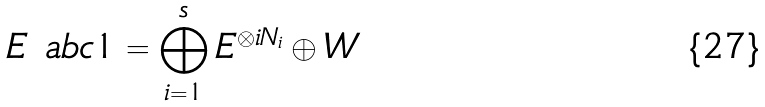<formula> <loc_0><loc_0><loc_500><loc_500>E \ a b c { 1 } = \bigoplus _ { i = 1 } ^ { s } E ^ { \otimes i N _ { i } } \oplus W</formula> 